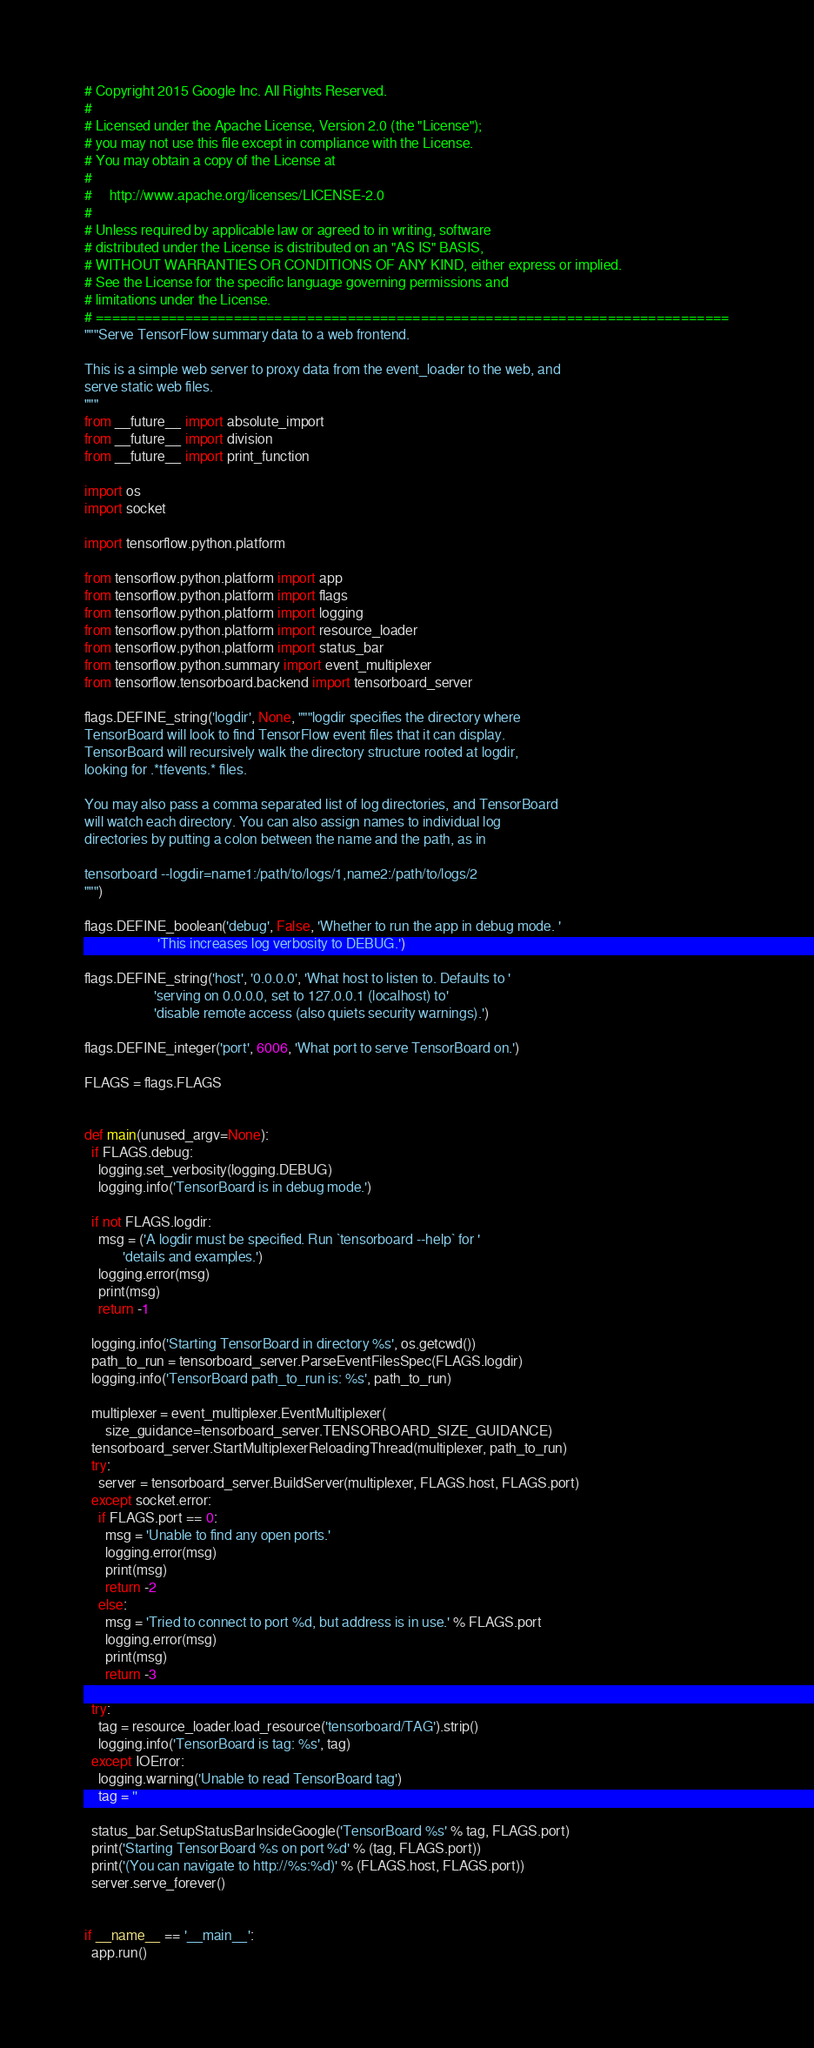Convert code to text. <code><loc_0><loc_0><loc_500><loc_500><_Python_># Copyright 2015 Google Inc. All Rights Reserved.
#
# Licensed under the Apache License, Version 2.0 (the "License");
# you may not use this file except in compliance with the License.
# You may obtain a copy of the License at
#
#     http://www.apache.org/licenses/LICENSE-2.0
#
# Unless required by applicable law or agreed to in writing, software
# distributed under the License is distributed on an "AS IS" BASIS,
# WITHOUT WARRANTIES OR CONDITIONS OF ANY KIND, either express or implied.
# See the License for the specific language governing permissions and
# limitations under the License.
# ==============================================================================
"""Serve TensorFlow summary data to a web frontend.

This is a simple web server to proxy data from the event_loader to the web, and
serve static web files.
"""
from __future__ import absolute_import
from __future__ import division
from __future__ import print_function

import os
import socket

import tensorflow.python.platform

from tensorflow.python.platform import app
from tensorflow.python.platform import flags
from tensorflow.python.platform import logging
from tensorflow.python.platform import resource_loader
from tensorflow.python.platform import status_bar
from tensorflow.python.summary import event_multiplexer
from tensorflow.tensorboard.backend import tensorboard_server

flags.DEFINE_string('logdir', None, """logdir specifies the directory where
TensorBoard will look to find TensorFlow event files that it can display.
TensorBoard will recursively walk the directory structure rooted at logdir,
looking for .*tfevents.* files.

You may also pass a comma separated list of log directories, and TensorBoard
will watch each directory. You can also assign names to individual log
directories by putting a colon between the name and the path, as in

tensorboard --logdir=name1:/path/to/logs/1,name2:/path/to/logs/2
""")

flags.DEFINE_boolean('debug', False, 'Whether to run the app in debug mode. '
                     'This increases log verbosity to DEBUG.')

flags.DEFINE_string('host', '0.0.0.0', 'What host to listen to. Defaults to '
                    'serving on 0.0.0.0, set to 127.0.0.1 (localhost) to'
                    'disable remote access (also quiets security warnings).')

flags.DEFINE_integer('port', 6006, 'What port to serve TensorBoard on.')

FLAGS = flags.FLAGS


def main(unused_argv=None):
  if FLAGS.debug:
    logging.set_verbosity(logging.DEBUG)
    logging.info('TensorBoard is in debug mode.')

  if not FLAGS.logdir:
    msg = ('A logdir must be specified. Run `tensorboard --help` for '
           'details and examples.')
    logging.error(msg)
    print(msg)
    return -1

  logging.info('Starting TensorBoard in directory %s', os.getcwd())
  path_to_run = tensorboard_server.ParseEventFilesSpec(FLAGS.logdir)
  logging.info('TensorBoard path_to_run is: %s', path_to_run)

  multiplexer = event_multiplexer.EventMultiplexer(
      size_guidance=tensorboard_server.TENSORBOARD_SIZE_GUIDANCE)
  tensorboard_server.StartMultiplexerReloadingThread(multiplexer, path_to_run)
  try:
    server = tensorboard_server.BuildServer(multiplexer, FLAGS.host, FLAGS.port)
  except socket.error:
    if FLAGS.port == 0:
      msg = 'Unable to find any open ports.'
      logging.error(msg)
      print(msg)
      return -2
    else:
      msg = 'Tried to connect to port %d, but address is in use.' % FLAGS.port
      logging.error(msg)
      print(msg)
      return -3

  try:
    tag = resource_loader.load_resource('tensorboard/TAG').strip()
    logging.info('TensorBoard is tag: %s', tag)
  except IOError:
    logging.warning('Unable to read TensorBoard tag')
    tag = ''

  status_bar.SetupStatusBarInsideGoogle('TensorBoard %s' % tag, FLAGS.port)
  print('Starting TensorBoard %s on port %d' % (tag, FLAGS.port))
  print('(You can navigate to http://%s:%d)' % (FLAGS.host, FLAGS.port))
  server.serve_forever()


if __name__ == '__main__':
  app.run()
</code> 